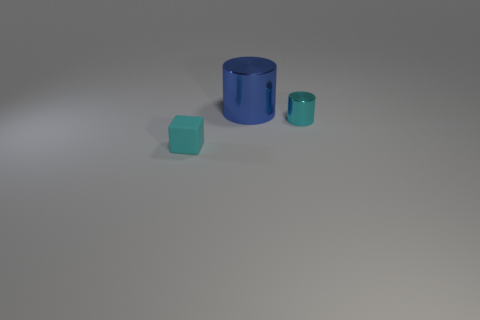Are there any other things that have the same material as the cyan cube?
Make the answer very short. No. Is there anything else that is the same size as the blue thing?
Offer a terse response. No. What number of blue metal things have the same size as the cyan shiny cylinder?
Your answer should be very brief. 0. How many rubber objects are small cyan cylinders or purple cubes?
Your response must be concise. 0. What material is the blue thing?
Your answer should be compact. Metal. There is a blue metallic thing; how many small cubes are to the left of it?
Your answer should be very brief. 1. Is the material of the cyan object that is to the right of the tiny matte object the same as the blue cylinder?
Provide a short and direct response. Yes. How many other matte objects have the same shape as the small cyan rubber object?
Offer a very short reply. 0. How many big things are either blocks or blue metal cubes?
Give a very brief answer. 0. There is a shiny thing that is to the left of the tiny shiny thing; is it the same color as the block?
Ensure brevity in your answer.  No. 